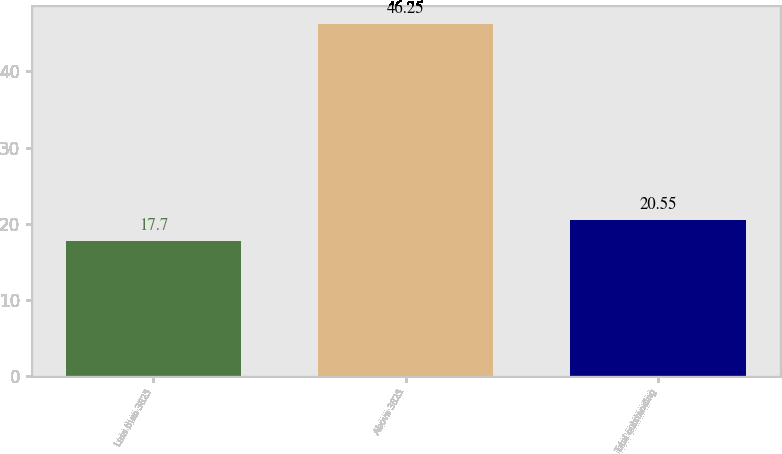<chart> <loc_0><loc_0><loc_500><loc_500><bar_chart><fcel>Less than 3825<fcel>Above 3825<fcel>Total outstanding<nl><fcel>17.7<fcel>46.25<fcel>20.55<nl></chart> 